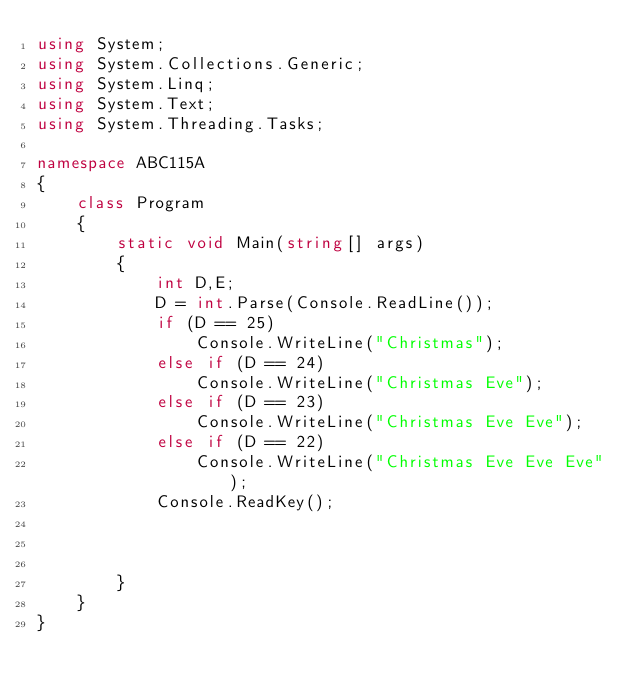Convert code to text. <code><loc_0><loc_0><loc_500><loc_500><_C#_>using System;
using System.Collections.Generic;
using System.Linq;
using System.Text;
using System.Threading.Tasks;

namespace ABC115A
{
    class Program
    {
        static void Main(string[] args)
        {
            int D,E;
            D = int.Parse(Console.ReadLine());
            if (D == 25)
                Console.WriteLine("Christmas");
            else if (D == 24)
                Console.WriteLine("Christmas Eve");
            else if (D == 23)
                Console.WriteLine("Christmas Eve Eve");
            else if (D == 22)
                Console.WriteLine("Christmas Eve Eve Eve");
            Console.ReadKey();



        }
    }
}</code> 